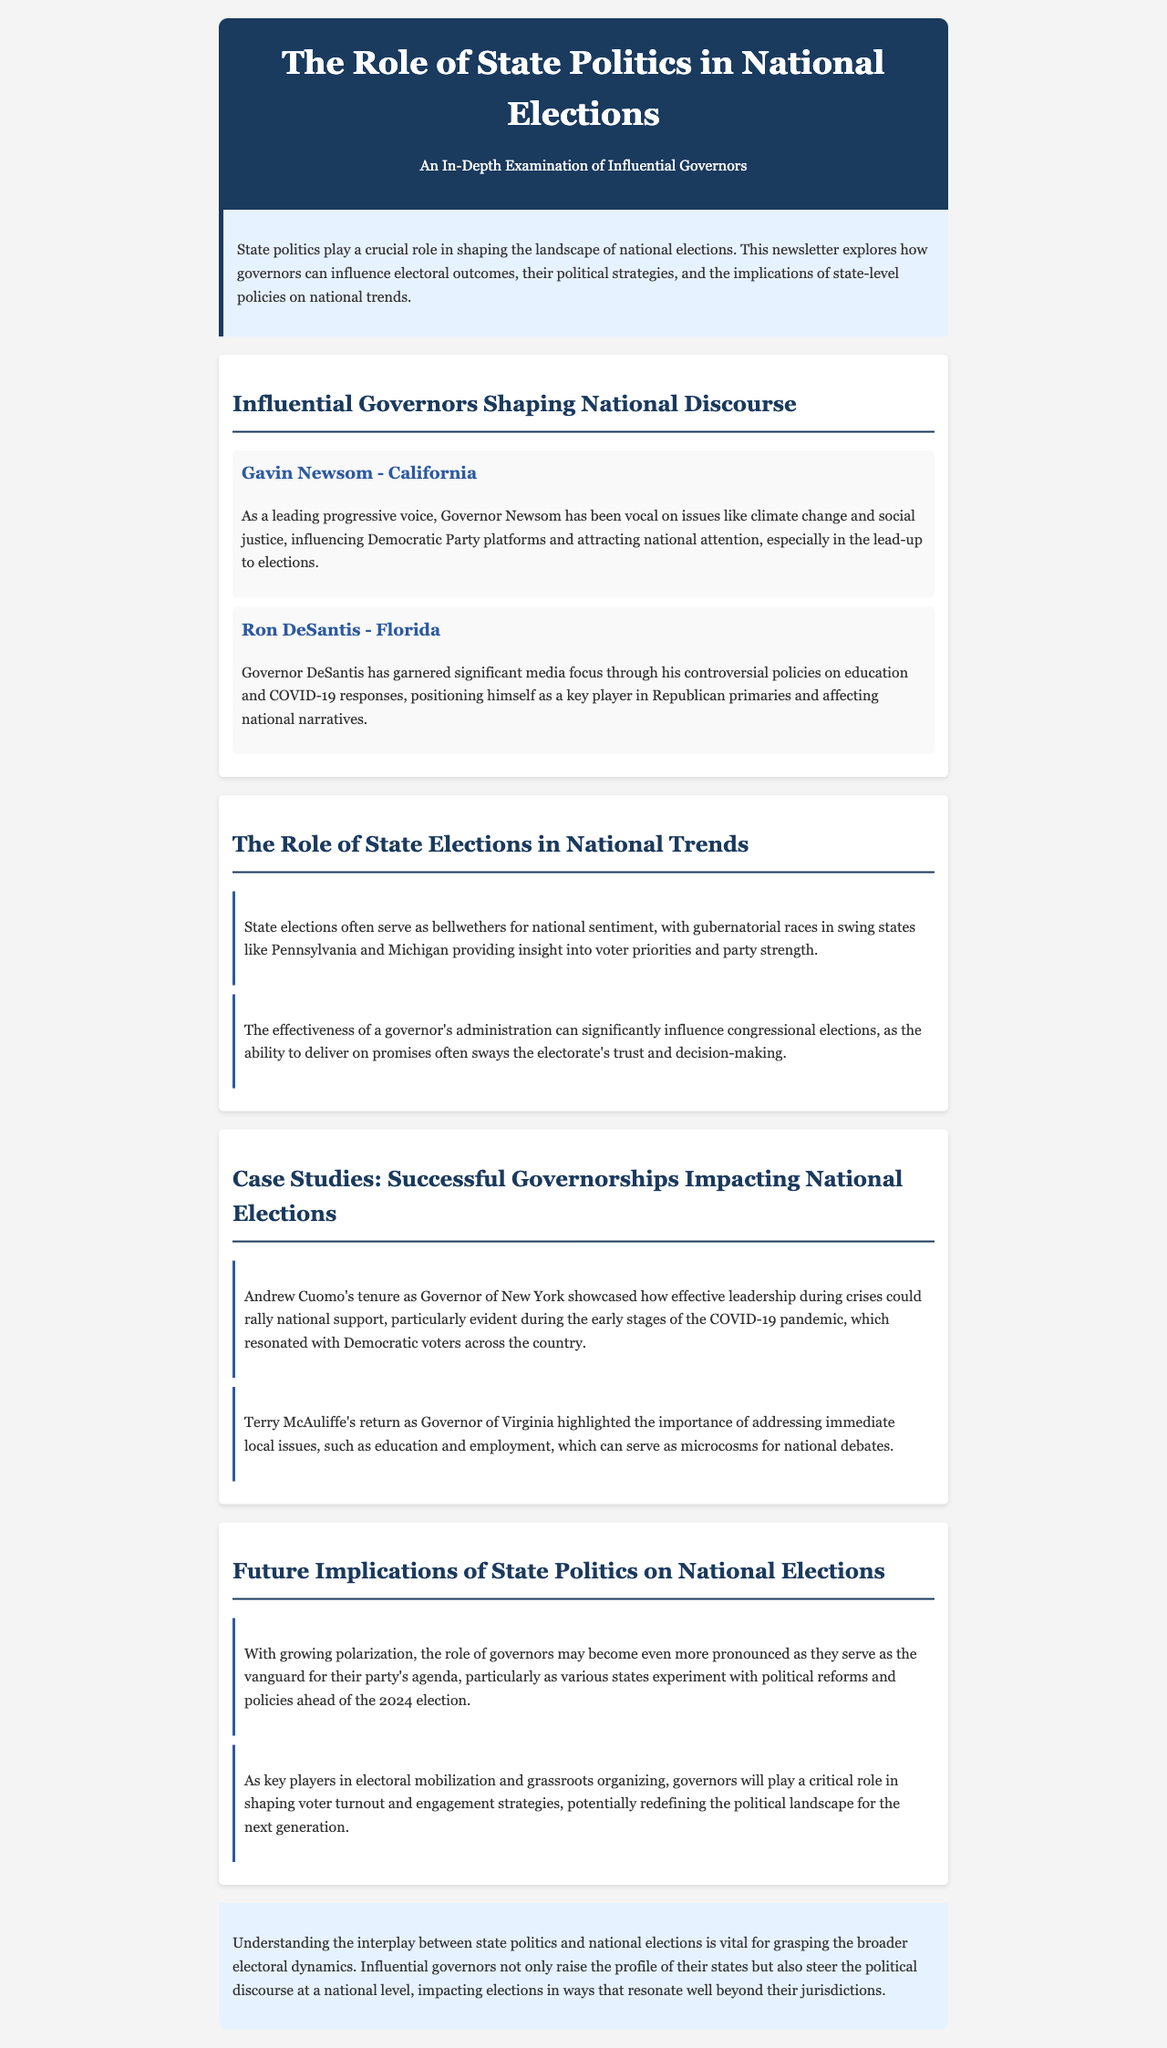What is the title of the newsletter? The title of the newsletter is prominently displayed in the header of the document.
Answer: The Role of State Politics in National Elections Who is the governor of California mentioned in the document? The document lists influential governors, specifically naming the governor of California.
Answer: Gavin Newsom What controversial policies has Ron DeSantis implemented? The document highlights the specific issues regarding which Ron DeSantis has garnered media focus, particularly mentioned in his description.
Answer: Education and COVID-19 responses Which state is highlighted as a bellwether for national sentiment? The document suggests states that often serve as indicators for national political trends, mentioning specific states in the context.
Answer: Pennsylvania What crisis did Andrew Cuomo's leadership during his governorship address? The document references a specific event during Cuomo's governorship that illustrates his leadership effectiveness.
Answer: COVID-19 pandemic What is a key role of governors according to the future implications section? The document outlines the critical functions that governors will perform in upcoming elections, focusing on their influence.
Answer: Mobilization and grassroots organizing Which governor's return addressed local issues in Virginia? The document provides examples of governors and describes specific events or actions related to them.
Answer: Terry McAuliffe What does the conclusion emphasize about the interplay of state politics and national elections? The conclusion summarizes the overall importance of the relationship between state governance and national electoral dynamics.
Answer: Vital understanding 